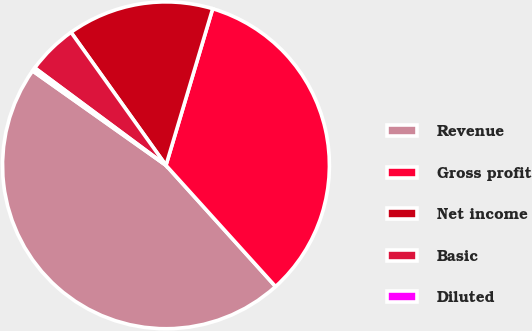<chart> <loc_0><loc_0><loc_500><loc_500><pie_chart><fcel>Revenue<fcel>Gross profit<fcel>Net income<fcel>Basic<fcel>Diluted<nl><fcel>46.5%<fcel>33.69%<fcel>14.48%<fcel>4.97%<fcel>0.36%<nl></chart> 